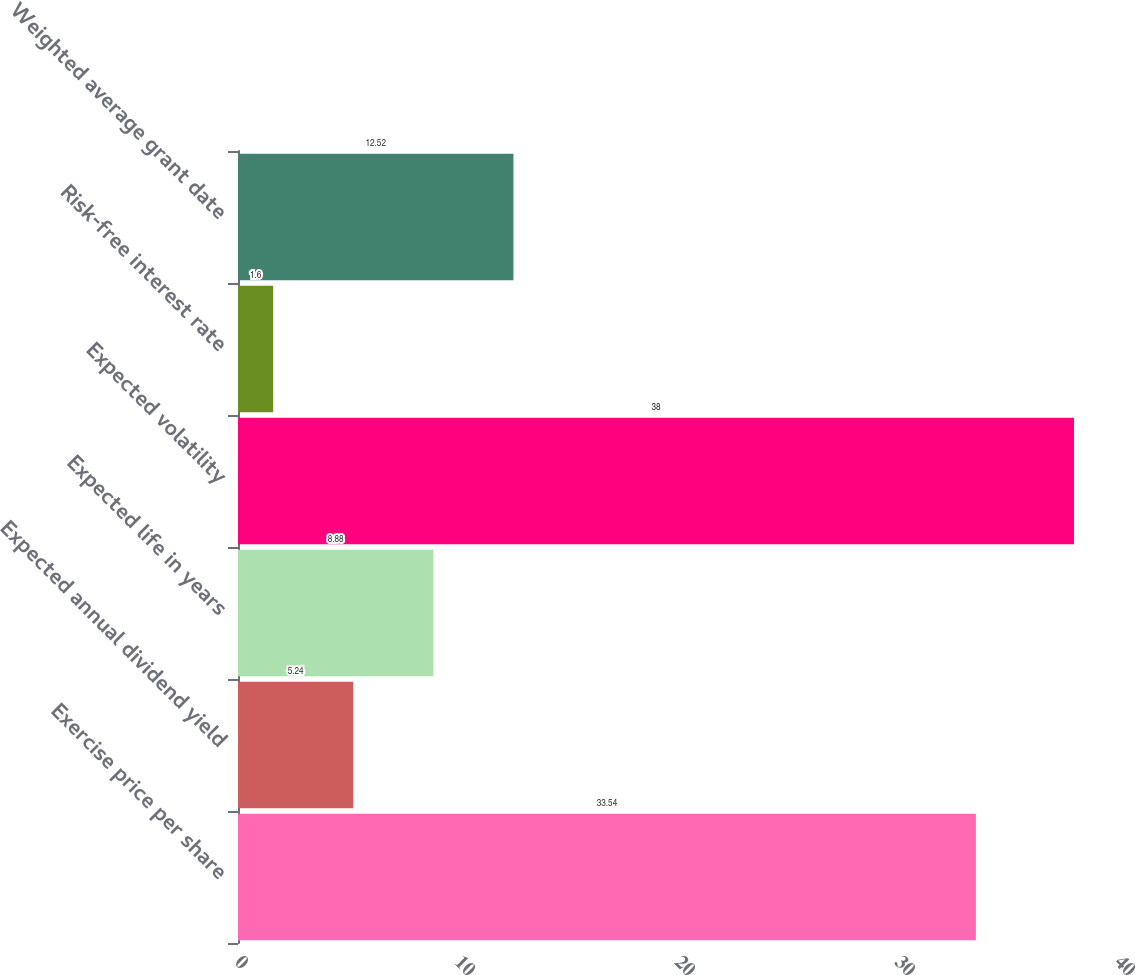Convert chart. <chart><loc_0><loc_0><loc_500><loc_500><bar_chart><fcel>Exercise price per share<fcel>Expected annual dividend yield<fcel>Expected life in years<fcel>Expected volatility<fcel>Risk-free interest rate<fcel>Weighted average grant date<nl><fcel>33.54<fcel>5.24<fcel>8.88<fcel>38<fcel>1.6<fcel>12.52<nl></chart> 